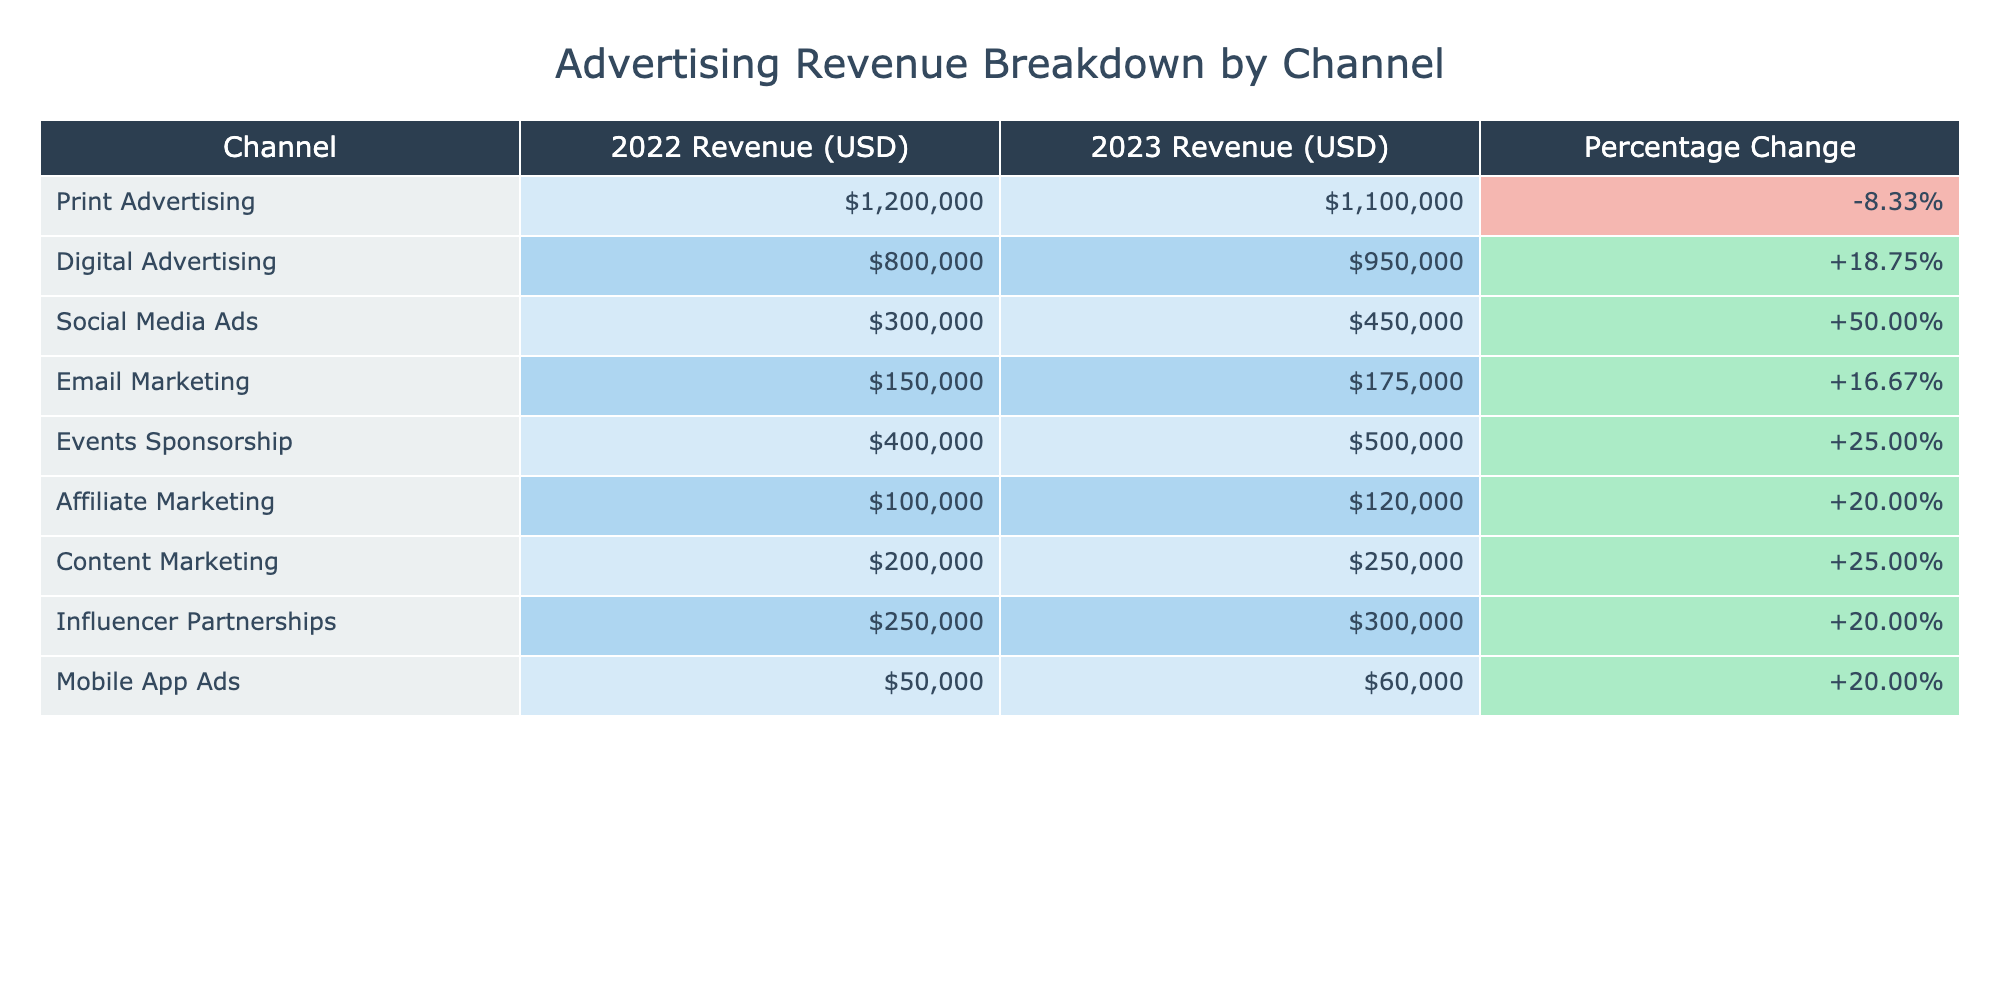What was the revenue from Digital Advertising in 2023? The table shows that the revenue for Digital Advertising in 2023 is listed as $950,000.
Answer: $950,000 Which channel had the highest percentage increase in revenue from 2022 to 2023? Looking at the 'Percentage Change' column, Social Media Ads had a percentage increase of 50.00%, which is the highest among all channels.
Answer: Social Media Ads Did Print Advertising experience a revenue increase from 2022 to 2023? The revenue from Print Advertising decreased from $1,200,000 in 2022 to $1,100,000 in 2023, indicating a decrease.
Answer: No What is the total revenue from Email Marketing and Affiliate Marketing combined in 2023? The revenue from Email Marketing in 2023 is $175,000 and from Affiliate Marketing is $120,000. Adding these gives $175,000 + $120,000 = $295,000.
Answer: $295,000 Did Influencer Partnerships generate more revenue than Mobile App Ads in 2023? The revenue from Influencer Partnerships in 2023 is $300,000, while Mobile App Ads generated $60,000. Since $300,000 is greater than $60,000, the answer is yes.
Answer: Yes What was the total revenue from all channels in 2022? Summing the revenues from all channels in 2022: $1,200,000 + $800,000 + $300,000 + $150,000 + $400,000 + $100,000 + $200,000 + $250,000 + $50,000 = $3,450,000.
Answer: $3,450,000 Which channel had a negative percentage change, and what was that change? The table shows that Print Advertising experienced a negative percentage change of -8.33%.
Answer: Print Advertising, -8.33% What was the percentage change for Content Marketing from 2022 to 2023? According to the table, Content Marketing had a percentage change of 25.00% from 2022 to 2023.
Answer: 25.00% 